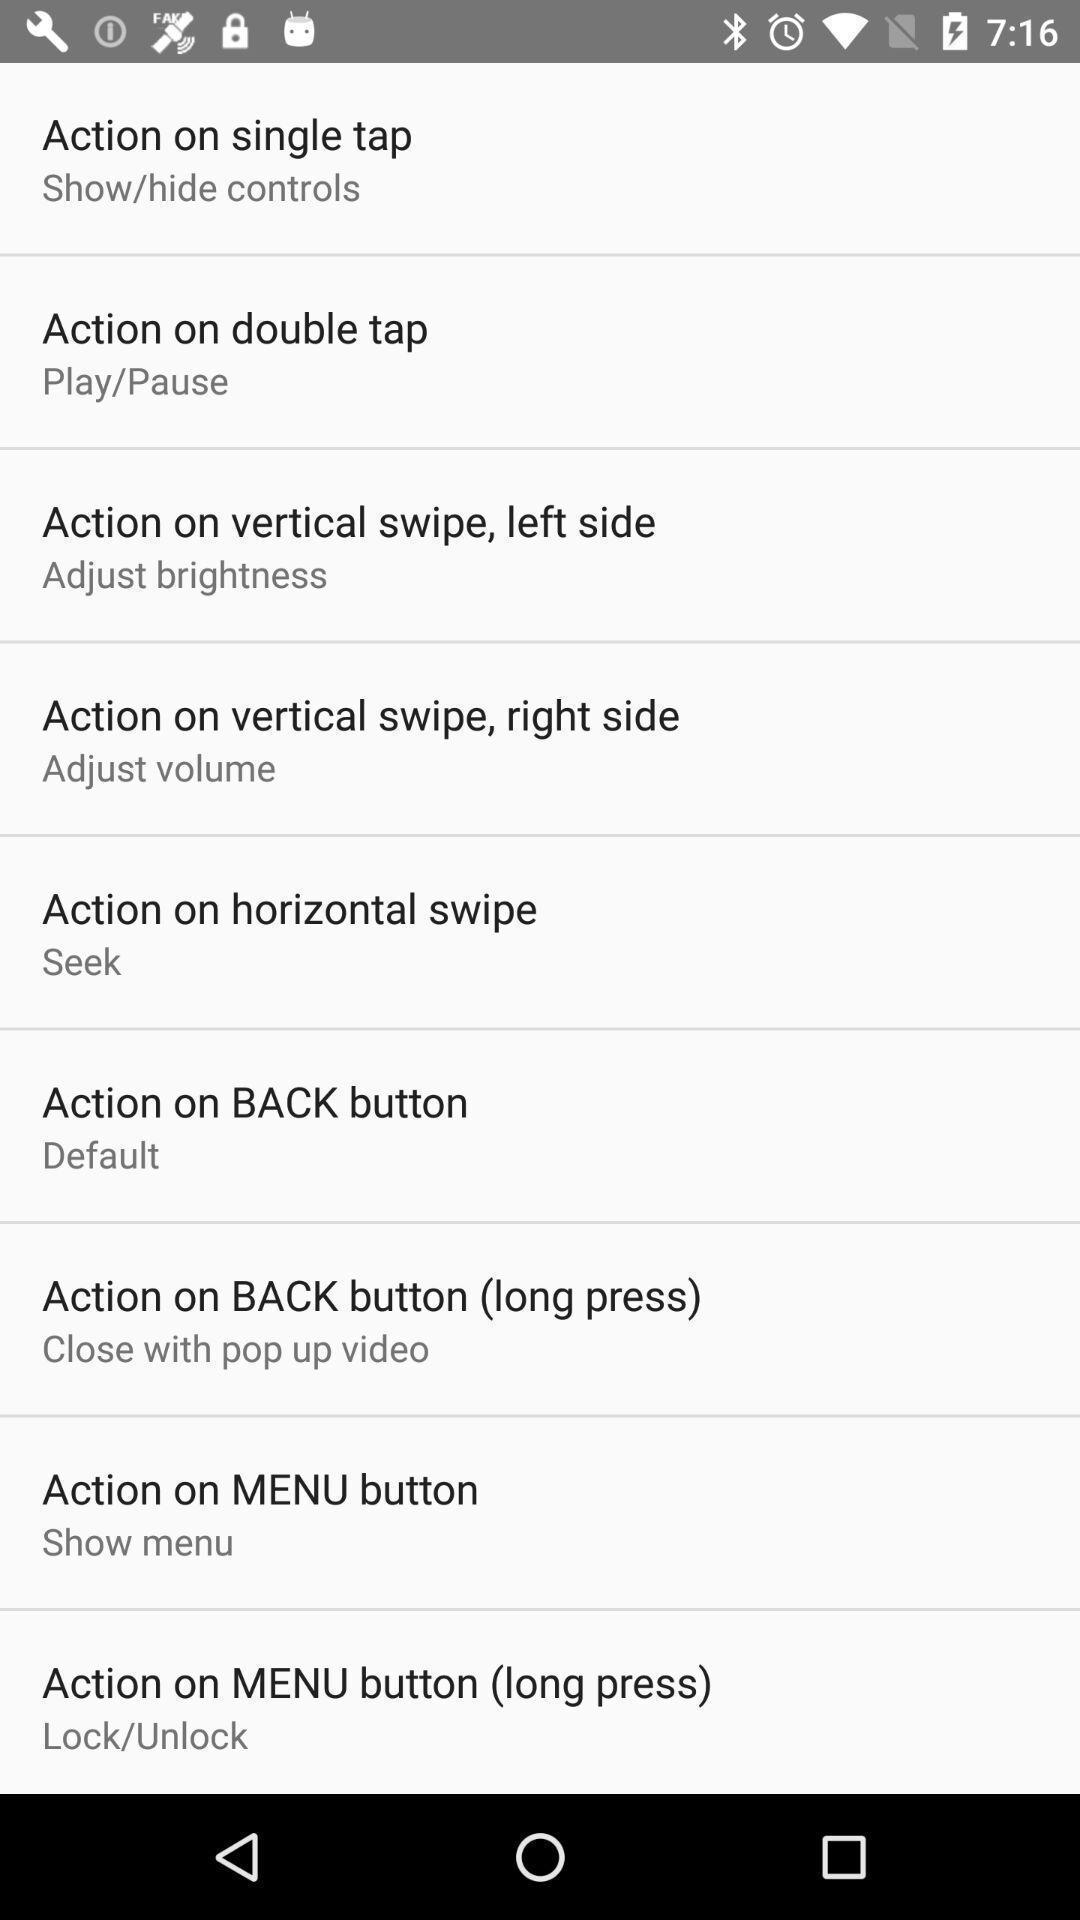Provide a description of this screenshot. Screen shows different settings on a device. 